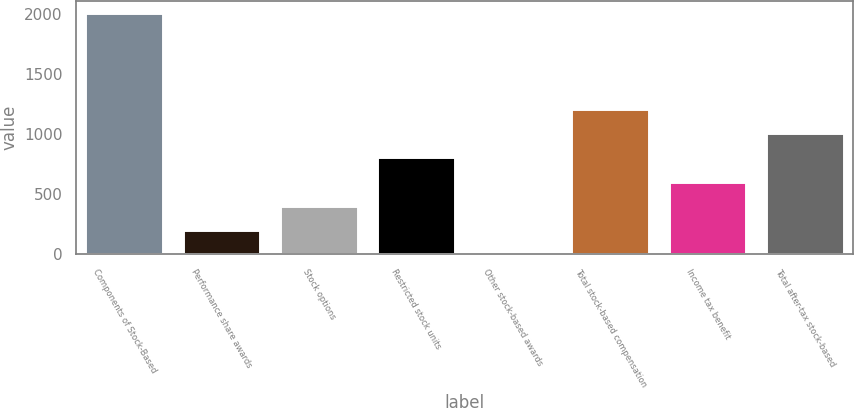Convert chart to OTSL. <chart><loc_0><loc_0><loc_500><loc_500><bar_chart><fcel>Components of Stock-Based<fcel>Performance share awards<fcel>Stock options<fcel>Restricted stock units<fcel>Other stock-based awards<fcel>Total stock-based compensation<fcel>Income tax benefit<fcel>Total after-tax stock-based<nl><fcel>2010<fcel>204.6<fcel>405.2<fcel>806.4<fcel>4<fcel>1207.6<fcel>605.8<fcel>1007<nl></chart> 